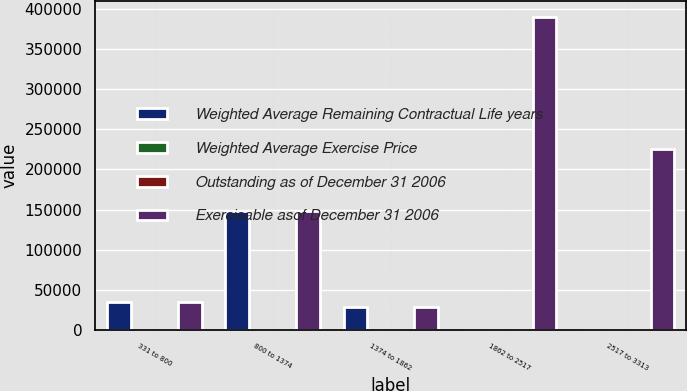<chart> <loc_0><loc_0><loc_500><loc_500><stacked_bar_chart><ecel><fcel>331 to 800<fcel>800 to 1374<fcel>1374 to 1862<fcel>1862 to 2517<fcel>2517 to 3313<nl><fcel>Weighted Average Remaining Contractual Life years<fcel>34757<fcel>148556<fcel>28374<fcel>26.335<fcel>26.335<nl><fcel>Weighted Average Exercise Price<fcel>3.6<fcel>3.9<fcel>3.5<fcel>7<fcel>8.7<nl><fcel>Outstanding as of December 31 2006<fcel>5.26<fcel>12.31<fcel>15.84<fcel>23.62<fcel>29.05<nl><fcel>Exercisable asof December 31 2006<fcel>34757<fcel>148556<fcel>28374<fcel>390230<fcel>225008<nl></chart> 